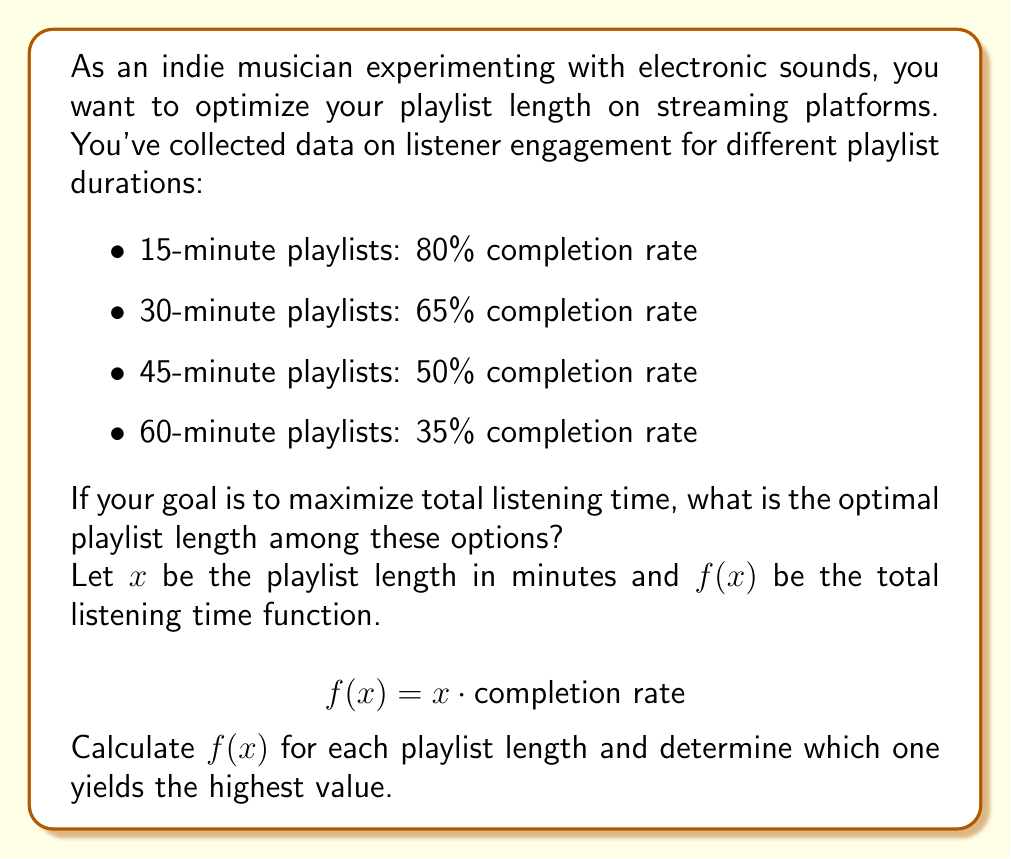What is the answer to this math problem? To solve this problem, we need to calculate the total listening time for each playlist length using the given function:

$$f(x) = x \cdot \text{completion rate}$$

Let's calculate for each option:

1. 15-minute playlist:
   $$f(15) = 15 \cdot 0.80 = 12 \text{ minutes}$$

2. 30-minute playlist:
   $$f(30) = 30 \cdot 0.65 = 19.5 \text{ minutes}$$

3. 45-minute playlist:
   $$f(45) = 45 \cdot 0.50 = 22.5 \text{ minutes}$$

4. 60-minute playlist:
   $$f(60) = 60 \cdot 0.35 = 21 \text{ minutes}$$

Comparing the results:
$$f(15) = 12 < f(30) = 19.5 < f(60) = 21 < f(45) = 22.5$$

The 45-minute playlist yields the highest total listening time of 22.5 minutes.
Answer: The optimal playlist length is 45 minutes, resulting in a maximum total listening time of 22.5 minutes. 